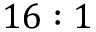Convert formula to latex. <formula><loc_0><loc_0><loc_500><loc_500>1 6 \colon 1</formula> 